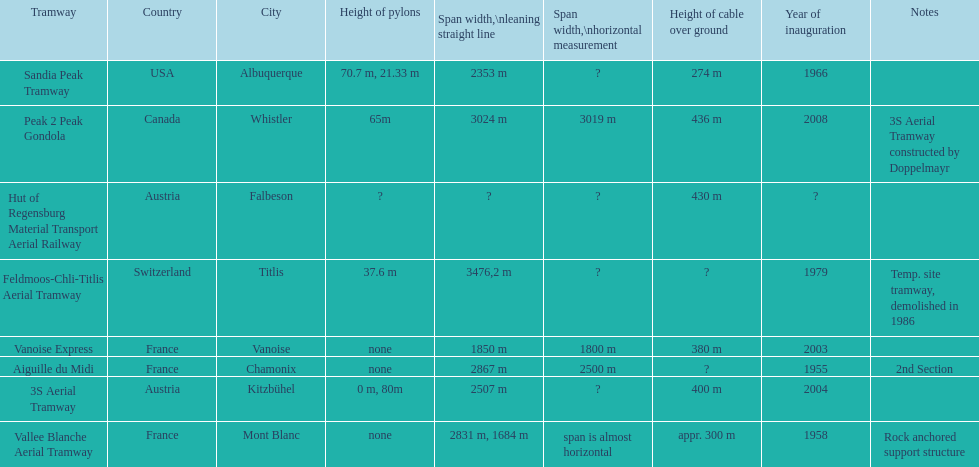Which tramway was inaugurated first, the 3s aerial tramway or the aiguille du midi? Aiguille du Midi. 